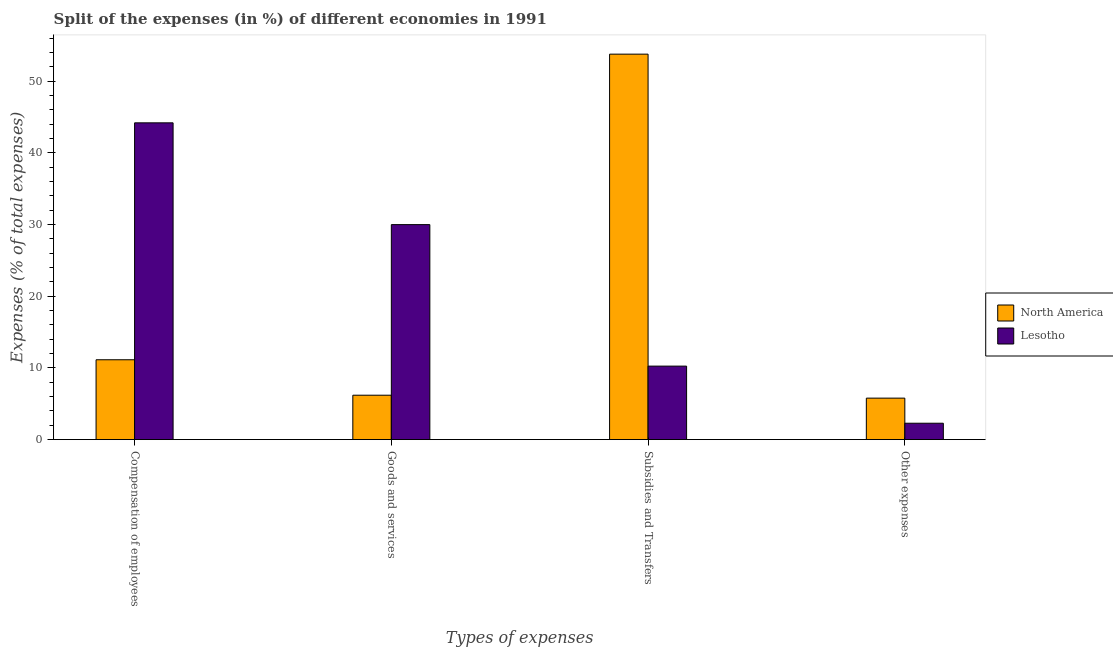Are the number of bars per tick equal to the number of legend labels?
Ensure brevity in your answer.  Yes. Are the number of bars on each tick of the X-axis equal?
Provide a succinct answer. Yes. How many bars are there on the 2nd tick from the left?
Provide a short and direct response. 2. How many bars are there on the 3rd tick from the right?
Your answer should be compact. 2. What is the label of the 4th group of bars from the left?
Make the answer very short. Other expenses. What is the percentage of amount spent on other expenses in Lesotho?
Provide a succinct answer. 2.28. Across all countries, what is the maximum percentage of amount spent on subsidies?
Your answer should be compact. 53.78. Across all countries, what is the minimum percentage of amount spent on compensation of employees?
Offer a terse response. 11.14. In which country was the percentage of amount spent on subsidies maximum?
Provide a short and direct response. North America. In which country was the percentage of amount spent on subsidies minimum?
Offer a terse response. Lesotho. What is the total percentage of amount spent on other expenses in the graph?
Your response must be concise. 8.07. What is the difference between the percentage of amount spent on subsidies in Lesotho and that in North America?
Your answer should be very brief. -43.53. What is the difference between the percentage of amount spent on goods and services in Lesotho and the percentage of amount spent on subsidies in North America?
Make the answer very short. -23.78. What is the average percentage of amount spent on subsidies per country?
Offer a very short reply. 32.02. What is the difference between the percentage of amount spent on other expenses and percentage of amount spent on subsidies in North America?
Your answer should be compact. -48. In how many countries, is the percentage of amount spent on subsidies greater than 50 %?
Provide a succinct answer. 1. What is the ratio of the percentage of amount spent on other expenses in Lesotho to that in North America?
Ensure brevity in your answer.  0.39. What is the difference between the highest and the second highest percentage of amount spent on other expenses?
Your response must be concise. 3.5. What is the difference between the highest and the lowest percentage of amount spent on goods and services?
Offer a terse response. 23.8. What does the 1st bar from the right in Goods and services represents?
Offer a terse response. Lesotho. Is it the case that in every country, the sum of the percentage of amount spent on compensation of employees and percentage of amount spent on goods and services is greater than the percentage of amount spent on subsidies?
Make the answer very short. No. How many bars are there?
Your answer should be compact. 8. What is the difference between two consecutive major ticks on the Y-axis?
Provide a short and direct response. 10. Are the values on the major ticks of Y-axis written in scientific E-notation?
Your answer should be compact. No. What is the title of the graph?
Make the answer very short. Split of the expenses (in %) of different economies in 1991. What is the label or title of the X-axis?
Ensure brevity in your answer.  Types of expenses. What is the label or title of the Y-axis?
Your answer should be very brief. Expenses (% of total expenses). What is the Expenses (% of total expenses) of North America in Compensation of employees?
Provide a succinct answer. 11.14. What is the Expenses (% of total expenses) of Lesotho in Compensation of employees?
Make the answer very short. 44.2. What is the Expenses (% of total expenses) of North America in Goods and services?
Keep it short and to the point. 6.19. What is the Expenses (% of total expenses) in Lesotho in Goods and services?
Offer a terse response. 30. What is the Expenses (% of total expenses) in North America in Subsidies and Transfers?
Give a very brief answer. 53.78. What is the Expenses (% of total expenses) of Lesotho in Subsidies and Transfers?
Offer a very short reply. 10.25. What is the Expenses (% of total expenses) in North America in Other expenses?
Provide a short and direct response. 5.79. What is the Expenses (% of total expenses) in Lesotho in Other expenses?
Offer a terse response. 2.28. Across all Types of expenses, what is the maximum Expenses (% of total expenses) of North America?
Provide a succinct answer. 53.78. Across all Types of expenses, what is the maximum Expenses (% of total expenses) in Lesotho?
Keep it short and to the point. 44.2. Across all Types of expenses, what is the minimum Expenses (% of total expenses) in North America?
Your response must be concise. 5.79. Across all Types of expenses, what is the minimum Expenses (% of total expenses) of Lesotho?
Make the answer very short. 2.28. What is the total Expenses (% of total expenses) in North America in the graph?
Give a very brief answer. 76.9. What is the total Expenses (% of total expenses) of Lesotho in the graph?
Give a very brief answer. 86.73. What is the difference between the Expenses (% of total expenses) in North America in Compensation of employees and that in Goods and services?
Your answer should be very brief. 4.95. What is the difference between the Expenses (% of total expenses) of Lesotho in Compensation of employees and that in Goods and services?
Your answer should be very brief. 14.2. What is the difference between the Expenses (% of total expenses) of North America in Compensation of employees and that in Subsidies and Transfers?
Your answer should be compact. -42.64. What is the difference between the Expenses (% of total expenses) in Lesotho in Compensation of employees and that in Subsidies and Transfers?
Ensure brevity in your answer.  33.95. What is the difference between the Expenses (% of total expenses) of North America in Compensation of employees and that in Other expenses?
Offer a terse response. 5.35. What is the difference between the Expenses (% of total expenses) in Lesotho in Compensation of employees and that in Other expenses?
Your answer should be compact. 41.91. What is the difference between the Expenses (% of total expenses) of North America in Goods and services and that in Subsidies and Transfers?
Ensure brevity in your answer.  -47.59. What is the difference between the Expenses (% of total expenses) of Lesotho in Goods and services and that in Subsidies and Transfers?
Offer a terse response. 19.74. What is the difference between the Expenses (% of total expenses) of North America in Goods and services and that in Other expenses?
Your answer should be compact. 0.41. What is the difference between the Expenses (% of total expenses) in Lesotho in Goods and services and that in Other expenses?
Ensure brevity in your answer.  27.71. What is the difference between the Expenses (% of total expenses) in North America in Subsidies and Transfers and that in Other expenses?
Make the answer very short. 48. What is the difference between the Expenses (% of total expenses) in Lesotho in Subsidies and Transfers and that in Other expenses?
Provide a short and direct response. 7.97. What is the difference between the Expenses (% of total expenses) of North America in Compensation of employees and the Expenses (% of total expenses) of Lesotho in Goods and services?
Your response must be concise. -18.86. What is the difference between the Expenses (% of total expenses) in North America in Compensation of employees and the Expenses (% of total expenses) in Lesotho in Subsidies and Transfers?
Your answer should be very brief. 0.89. What is the difference between the Expenses (% of total expenses) of North America in Compensation of employees and the Expenses (% of total expenses) of Lesotho in Other expenses?
Provide a short and direct response. 8.86. What is the difference between the Expenses (% of total expenses) of North America in Goods and services and the Expenses (% of total expenses) of Lesotho in Subsidies and Transfers?
Your response must be concise. -4.06. What is the difference between the Expenses (% of total expenses) in North America in Goods and services and the Expenses (% of total expenses) in Lesotho in Other expenses?
Provide a succinct answer. 3.91. What is the difference between the Expenses (% of total expenses) in North America in Subsidies and Transfers and the Expenses (% of total expenses) in Lesotho in Other expenses?
Offer a very short reply. 51.5. What is the average Expenses (% of total expenses) of North America per Types of expenses?
Offer a terse response. 19.23. What is the average Expenses (% of total expenses) of Lesotho per Types of expenses?
Offer a very short reply. 21.68. What is the difference between the Expenses (% of total expenses) of North America and Expenses (% of total expenses) of Lesotho in Compensation of employees?
Ensure brevity in your answer.  -33.06. What is the difference between the Expenses (% of total expenses) in North America and Expenses (% of total expenses) in Lesotho in Goods and services?
Give a very brief answer. -23.8. What is the difference between the Expenses (% of total expenses) of North America and Expenses (% of total expenses) of Lesotho in Subsidies and Transfers?
Your answer should be compact. 43.53. What is the difference between the Expenses (% of total expenses) in North America and Expenses (% of total expenses) in Lesotho in Other expenses?
Keep it short and to the point. 3.5. What is the ratio of the Expenses (% of total expenses) in North America in Compensation of employees to that in Goods and services?
Offer a very short reply. 1.8. What is the ratio of the Expenses (% of total expenses) of Lesotho in Compensation of employees to that in Goods and services?
Provide a succinct answer. 1.47. What is the ratio of the Expenses (% of total expenses) of North America in Compensation of employees to that in Subsidies and Transfers?
Your response must be concise. 0.21. What is the ratio of the Expenses (% of total expenses) of Lesotho in Compensation of employees to that in Subsidies and Transfers?
Make the answer very short. 4.31. What is the ratio of the Expenses (% of total expenses) in North America in Compensation of employees to that in Other expenses?
Provide a succinct answer. 1.93. What is the ratio of the Expenses (% of total expenses) in Lesotho in Compensation of employees to that in Other expenses?
Your answer should be compact. 19.35. What is the ratio of the Expenses (% of total expenses) in North America in Goods and services to that in Subsidies and Transfers?
Ensure brevity in your answer.  0.12. What is the ratio of the Expenses (% of total expenses) of Lesotho in Goods and services to that in Subsidies and Transfers?
Provide a succinct answer. 2.93. What is the ratio of the Expenses (% of total expenses) of North America in Goods and services to that in Other expenses?
Keep it short and to the point. 1.07. What is the ratio of the Expenses (% of total expenses) of Lesotho in Goods and services to that in Other expenses?
Provide a succinct answer. 13.13. What is the ratio of the Expenses (% of total expenses) in North America in Subsidies and Transfers to that in Other expenses?
Make the answer very short. 9.3. What is the ratio of the Expenses (% of total expenses) in Lesotho in Subsidies and Transfers to that in Other expenses?
Your response must be concise. 4.49. What is the difference between the highest and the second highest Expenses (% of total expenses) of North America?
Your answer should be very brief. 42.64. What is the difference between the highest and the second highest Expenses (% of total expenses) of Lesotho?
Give a very brief answer. 14.2. What is the difference between the highest and the lowest Expenses (% of total expenses) in North America?
Provide a succinct answer. 48. What is the difference between the highest and the lowest Expenses (% of total expenses) in Lesotho?
Ensure brevity in your answer.  41.91. 